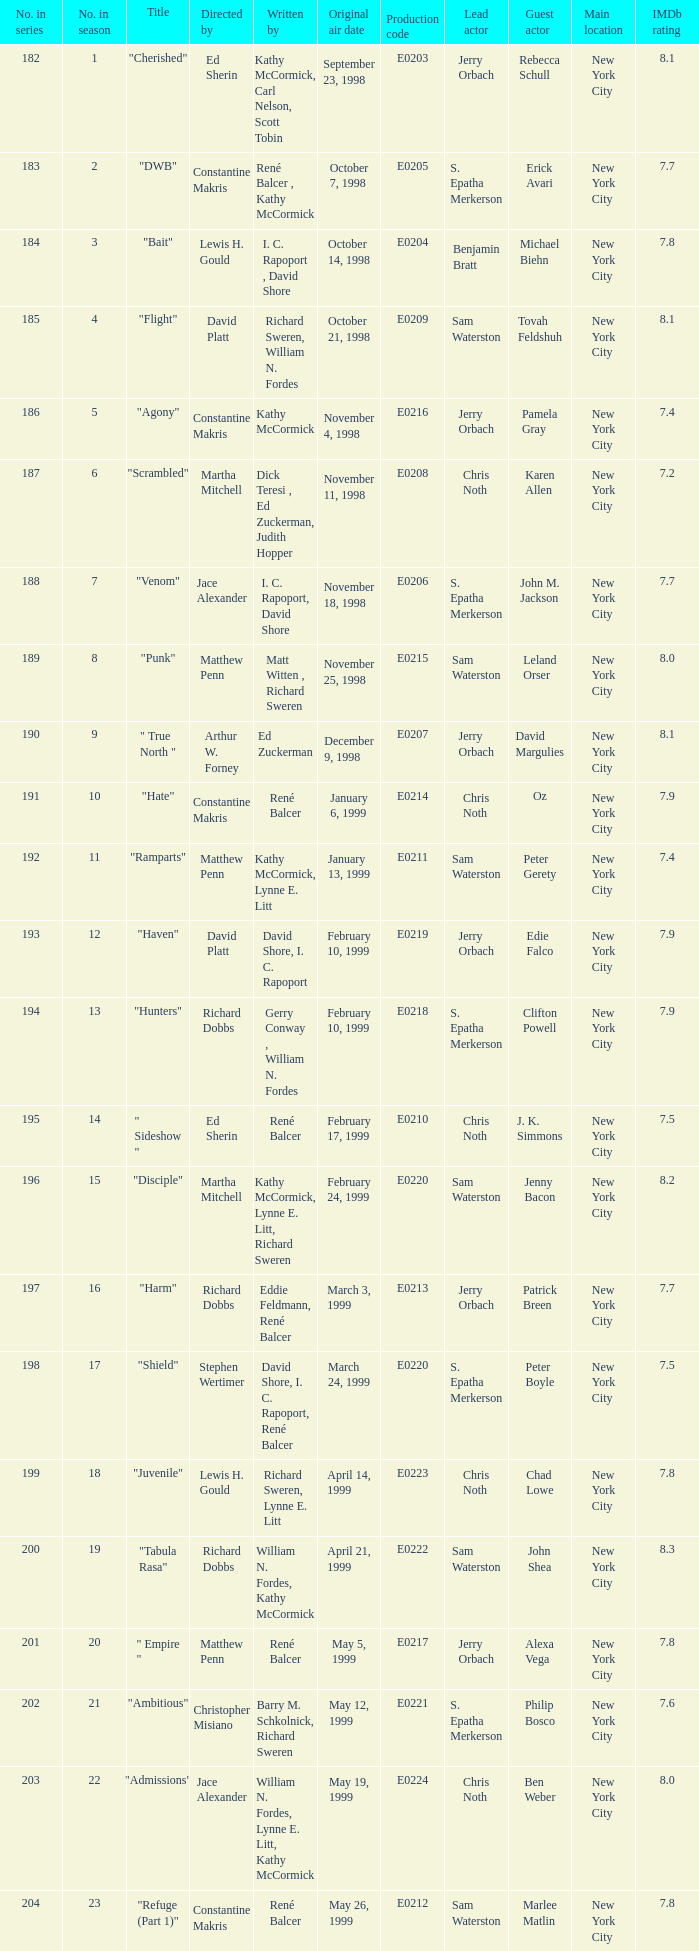The episode with original air date January 13, 1999 is written by who? Kathy McCormick, Lynne E. Litt. 